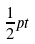Convert formula to latex. <formula><loc_0><loc_0><loc_500><loc_500>\frac { 1 } { 2 } p t</formula> 